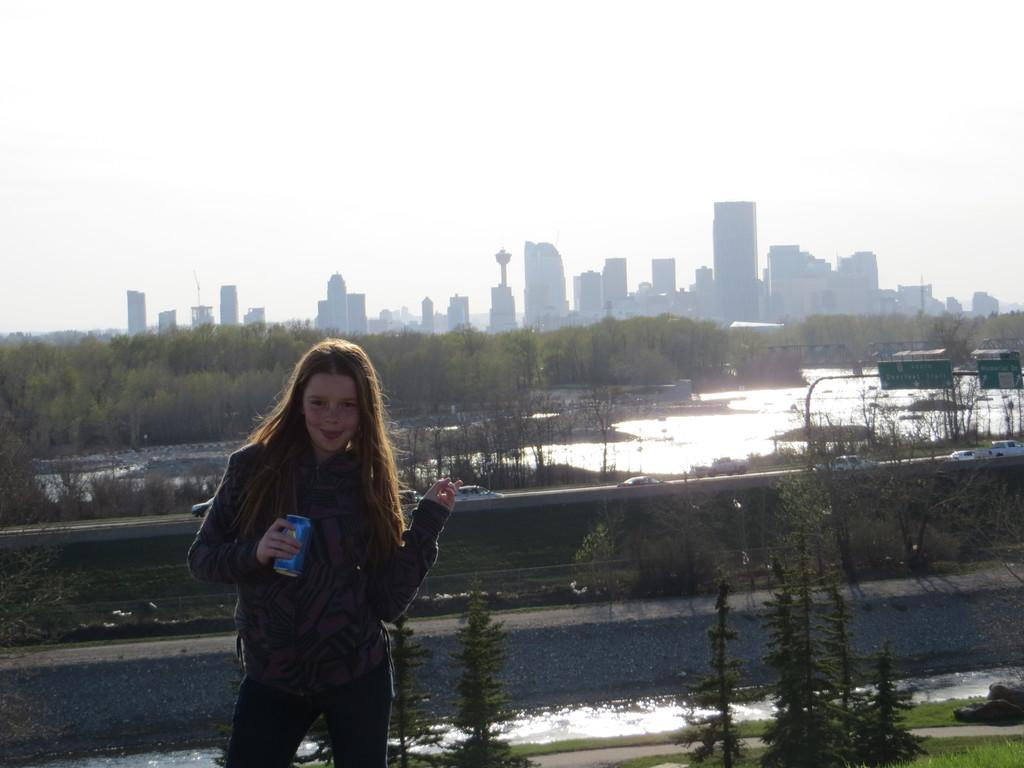What is the person holding in the image? The person is holding a tin in the image. What can be seen in the background of the image? There are trees, buildings, cars on the road, a sign board on a pole, water, and the sky visible in the background of the image. What grade did the person receive on their history exam, as shown in the image? There is no information about a history exam or a grade in the image. 